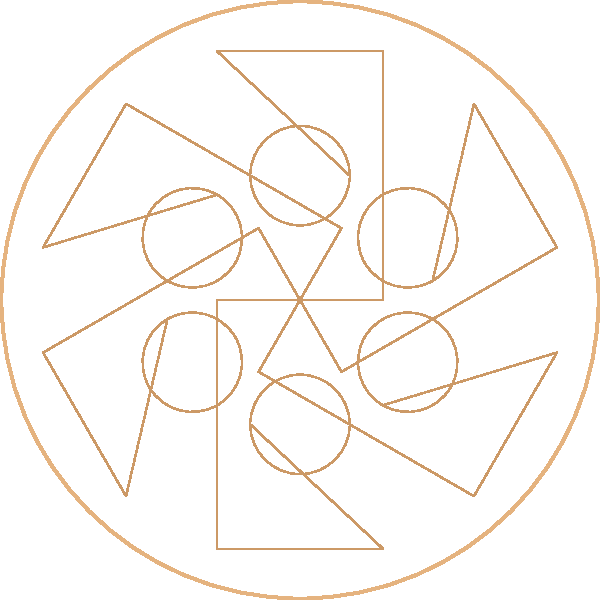In Samia's latest music video, a rotating guitar shape creates a star-like pattern. If the guitar shape is rotated around a fixed point to form a complete star, how many degrees should it be rotated each time to create a 6-pointed star pattern? Let's approach this step-by-step:

1. We need to create a 6-pointed star pattern, which means the guitar shape will appear 6 times in the full rotation.

2. A full rotation is 360°.

3. To find the angle of rotation for each guitar shape, we need to divide the full rotation by the number of points in the star:

   $$\text{Angle of rotation} = \frac{\text{Full rotation}}{\text{Number of points}}$$

4. Substituting the values:

   $$\text{Angle of rotation} = \frac{360°}{6}$$

5. Calculating:

   $$\text{Angle of rotation} = 60°$$

Therefore, to create a 6-pointed star pattern, the guitar shape should be rotated 60° each time.
Answer: 60° 